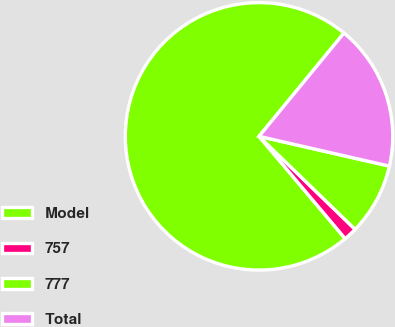Convert chart to OTSL. <chart><loc_0><loc_0><loc_500><loc_500><pie_chart><fcel>Model<fcel>757<fcel>777<fcel>Total<nl><fcel>72.09%<fcel>1.62%<fcel>8.67%<fcel>17.62%<nl></chart> 